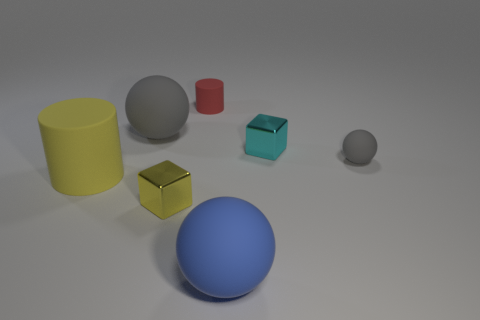What can you tell me about the colors and materials of the objects? The objects exhibit a variety of colors and materials. The yellow cylinder and cube appear to have a metallic sheen, indicating they are made of metal. The large grey sphere and small grey sphere seem to have a matte surface, suggesting they are made of rubber. The small red cylinder has a less reflective matte finish, and the teal cube has a slightly reflective surface, though the materials are not distinctly identifiable from the image alone. 